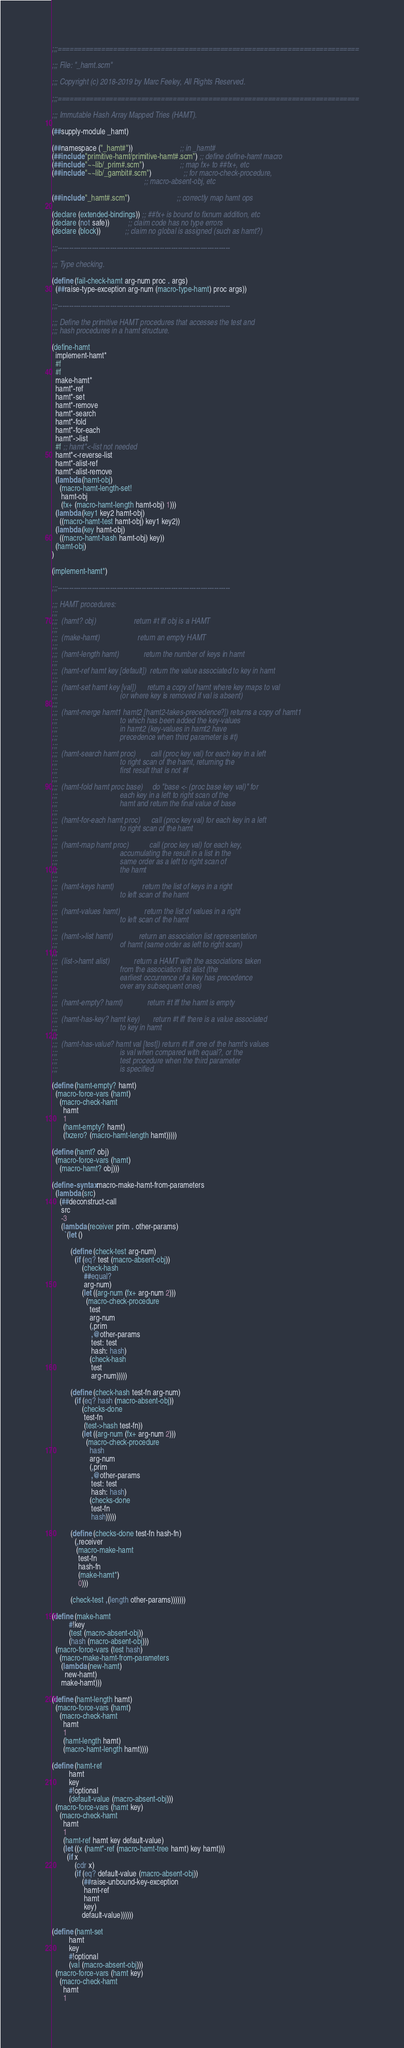Convert code to text. <code><loc_0><loc_0><loc_500><loc_500><_Scheme_>;;;============================================================================

;;; File: "_hamt.scm"

;;; Copyright (c) 2018-2019 by Marc Feeley, All Rights Reserved.

;;;============================================================================

;;; Immutable Hash Array Mapped Tries (HAMT).

(##supply-module _hamt)

(##namespace ("_hamt#"))                         ;; in _hamt#
(##include "primitive-hamt/primitive-hamt#.scm") ;; define define-hamt macro
(##include "~~lib/_prim#.scm")                   ;; map fx+ to ##fx+, etc
(##include "~~lib/_gambit#.scm")                 ;; for macro-check-procedure,
                                                 ;; macro-absent-obj, etc

(##include "_hamt#.scm")                         ;; correctly map hamt ops

(declare (extended-bindings)) ;; ##fx+ is bound to fixnum addition, etc
(declare (not safe))          ;; claim code has no type errors
(declare (block))             ;; claim no global is assigned (such as hamt?)

;;;----------------------------------------------------------------------------

;;; Type checking.

(define (fail-check-hamt arg-num proc . args)
  (##raise-type-exception arg-num (macro-type-hamt) proc args))

;;;----------------------------------------------------------------------------

;;; Define the primitive HAMT procedures that accesses the test and
;;; hash procedures in a hamt structure.

(define-hamt
  implement-hamt*
  #f
  #f
  make-hamt*
  hamt*-ref
  hamt*-set
  hamt*-remove
  hamt*-search
  hamt*-fold
  hamt*-for-each
  hamt*->list
  #f ;; hamt*<-list not needed
  hamt*<-reverse-list
  hamt*-alist-ref
  hamt*-alist-remove
  (lambda (hamt-obj)
    (macro-hamt-length-set!
     hamt-obj
     (fx+ (macro-hamt-length hamt-obj) 1)))
  (lambda (key1 key2 hamt-obj)
    ((macro-hamt-test hamt-obj) key1 key2))
  (lambda (key hamt-obj)
    ((macro-hamt-hash hamt-obj) key))
  (hamt-obj)
)

(implement-hamt*)

;;;----------------------------------------------------------------------------

;;; HAMT procedures:
;;;
;;;  (hamt? obj)                    return #t iff obj is a HAMT
;;;
;;;  (make-hamt)                    return an empty HAMT
;;;
;;;  (hamt-length hamt)             return the number of keys in hamt
;;;
;;;  (hamt-ref hamt key [default])  return the value associated to key in hamt
;;;
;;;  (hamt-set hamt key [val])      return a copy of hamt where key maps to val
;;;                                 (or where key is removed if val is absent)
;;;
;;;  (hamt-merge hamt1 hamt2 [hamt2-takes-precedence?]) returns a copy of hamt1
;;;                                 to which has been added the key-values
;;;                                 in hamt2 (key-values in hamt2 have
;;;                                 precedence when third parameter is #t)
;;;
;;;  (hamt-search hamt proc)        call (proc key val) for each key in a left
;;;                                 to right scan of the hamt, returning the
;;;                                 first result that is not #f
;;;
;;;  (hamt-fold hamt proc base)     do "base <- (proc base key val)" for
;;;                                 each key in a left to right scan of the
;;;                                 hamt and return the final value of base
;;;
;;;  (hamt-for-each hamt proc)      call (proc key val) for each key in a left
;;;                                 to right scan of the hamt
;;;
;;;  (hamt-map hamt proc)           call (proc key val) for each key,
;;;                                 accumulating the result in a list in the
;;;                                 same order as a left to right scan of
;;;                                 the hamt
;;;
;;;  (hamt-keys hamt)               return the list of keys in a right
;;;                                 to left scan of the hamt
;;;
;;;  (hamt-values hamt)             return the list of values in a right
;;;                                 to left scan of the hamt
;;;
;;;  (hamt->list hamt)              return an association list representation
;;;                                 of hamt (same order as left to right scan)
;;;
;;;  (list->hamt alist)             return a HAMT with the associations taken
;;;                                 from the association list alist (the
;;;                                 earliest occurrence of a key has precedence
;;;                                 over any subsequent ones)
;;;
;;;  (hamt-empty? hamt)             return #t iff the hamt is empty
;;;
;;;  (hamt-has-key? hamt key)       return #t iff there is a value associated
;;;                                 to key in hamt
;;;
;;;  (hamt-has-value? hamt val [test]) return #t iff one of the hamt's values
;;;                                 is val when compared with equal?, or the
;;;                                 test procedure when the third parameter
;;;                                 is specified

(define (hamt-empty? hamt)
  (macro-force-vars (hamt)
    (macro-check-hamt
      hamt
      1
      (hamt-empty? hamt)
      (fxzero? (macro-hamt-length hamt)))))

(define (hamt? obj)
  (macro-force-vars (hamt)
    (macro-hamt? obj)))

(define-syntax macro-make-hamt-from-parameters
  (lambda (src)
    (##deconstruct-call
     src
     -3
     (lambda (receiver prim . other-params)
       `(let ()

          (define (check-test arg-num)
            (if (eq? test (macro-absent-obj))
                (check-hash
                 ##equal?
                 arg-num)
                (let ((arg-num (fx+ arg-num 2)))
                  (macro-check-procedure
                    test
                    arg-num
                    (,prim
                     ,@other-params
                     test: test
                     hash: hash)
                    (check-hash
                     test
                     arg-num)))))

          (define (check-hash test-fn arg-num)
            (if (eq? hash (macro-absent-obj))
                (checks-done
                 test-fn
                 (test->hash test-fn))
                (let ((arg-num (fx+ arg-num 2)))
                  (macro-check-procedure
                    hash
                    arg-num
                    (,prim
                     ,@other-params
                     test: test
                     hash: hash)
                    (checks-done
                     test-fn
                     hash)))))

          (define (checks-done test-fn hash-fn)
            (,receiver
             (macro-make-hamt
              test-fn
              hash-fn
              (make-hamt*)
              0)))

          (check-test ,(length other-params)))))))

(define (make-hamt
         #!key
         (test (macro-absent-obj))
         (hash (macro-absent-obj)))
  (macro-force-vars (test hash)
    (macro-make-hamt-from-parameters
     (lambda (new-hamt)
       new-hamt)
     make-hamt)))

(define (hamt-length hamt)
  (macro-force-vars (hamt)
    (macro-check-hamt
      hamt
      1
      (hamt-length hamt)
      (macro-hamt-length hamt))))

(define (hamt-ref
         hamt
         key
         #!optional
         (default-value (macro-absent-obj)))
  (macro-force-vars (hamt key)
    (macro-check-hamt
      hamt
      1
      (hamt-ref hamt key default-value)
      (let ((x (hamt*-ref (macro-hamt-tree hamt) key hamt)))
        (if x
            (cdr x)
            (if (eq? default-value (macro-absent-obj))
                (##raise-unbound-key-exception
                 hamt-ref
                 hamt
                 key)
                default-value))))))

(define (hamt-set
         hamt
         key
         #!optional
         (val (macro-absent-obj)))
  (macro-force-vars (hamt key)
    (macro-check-hamt
      hamt
      1</code> 